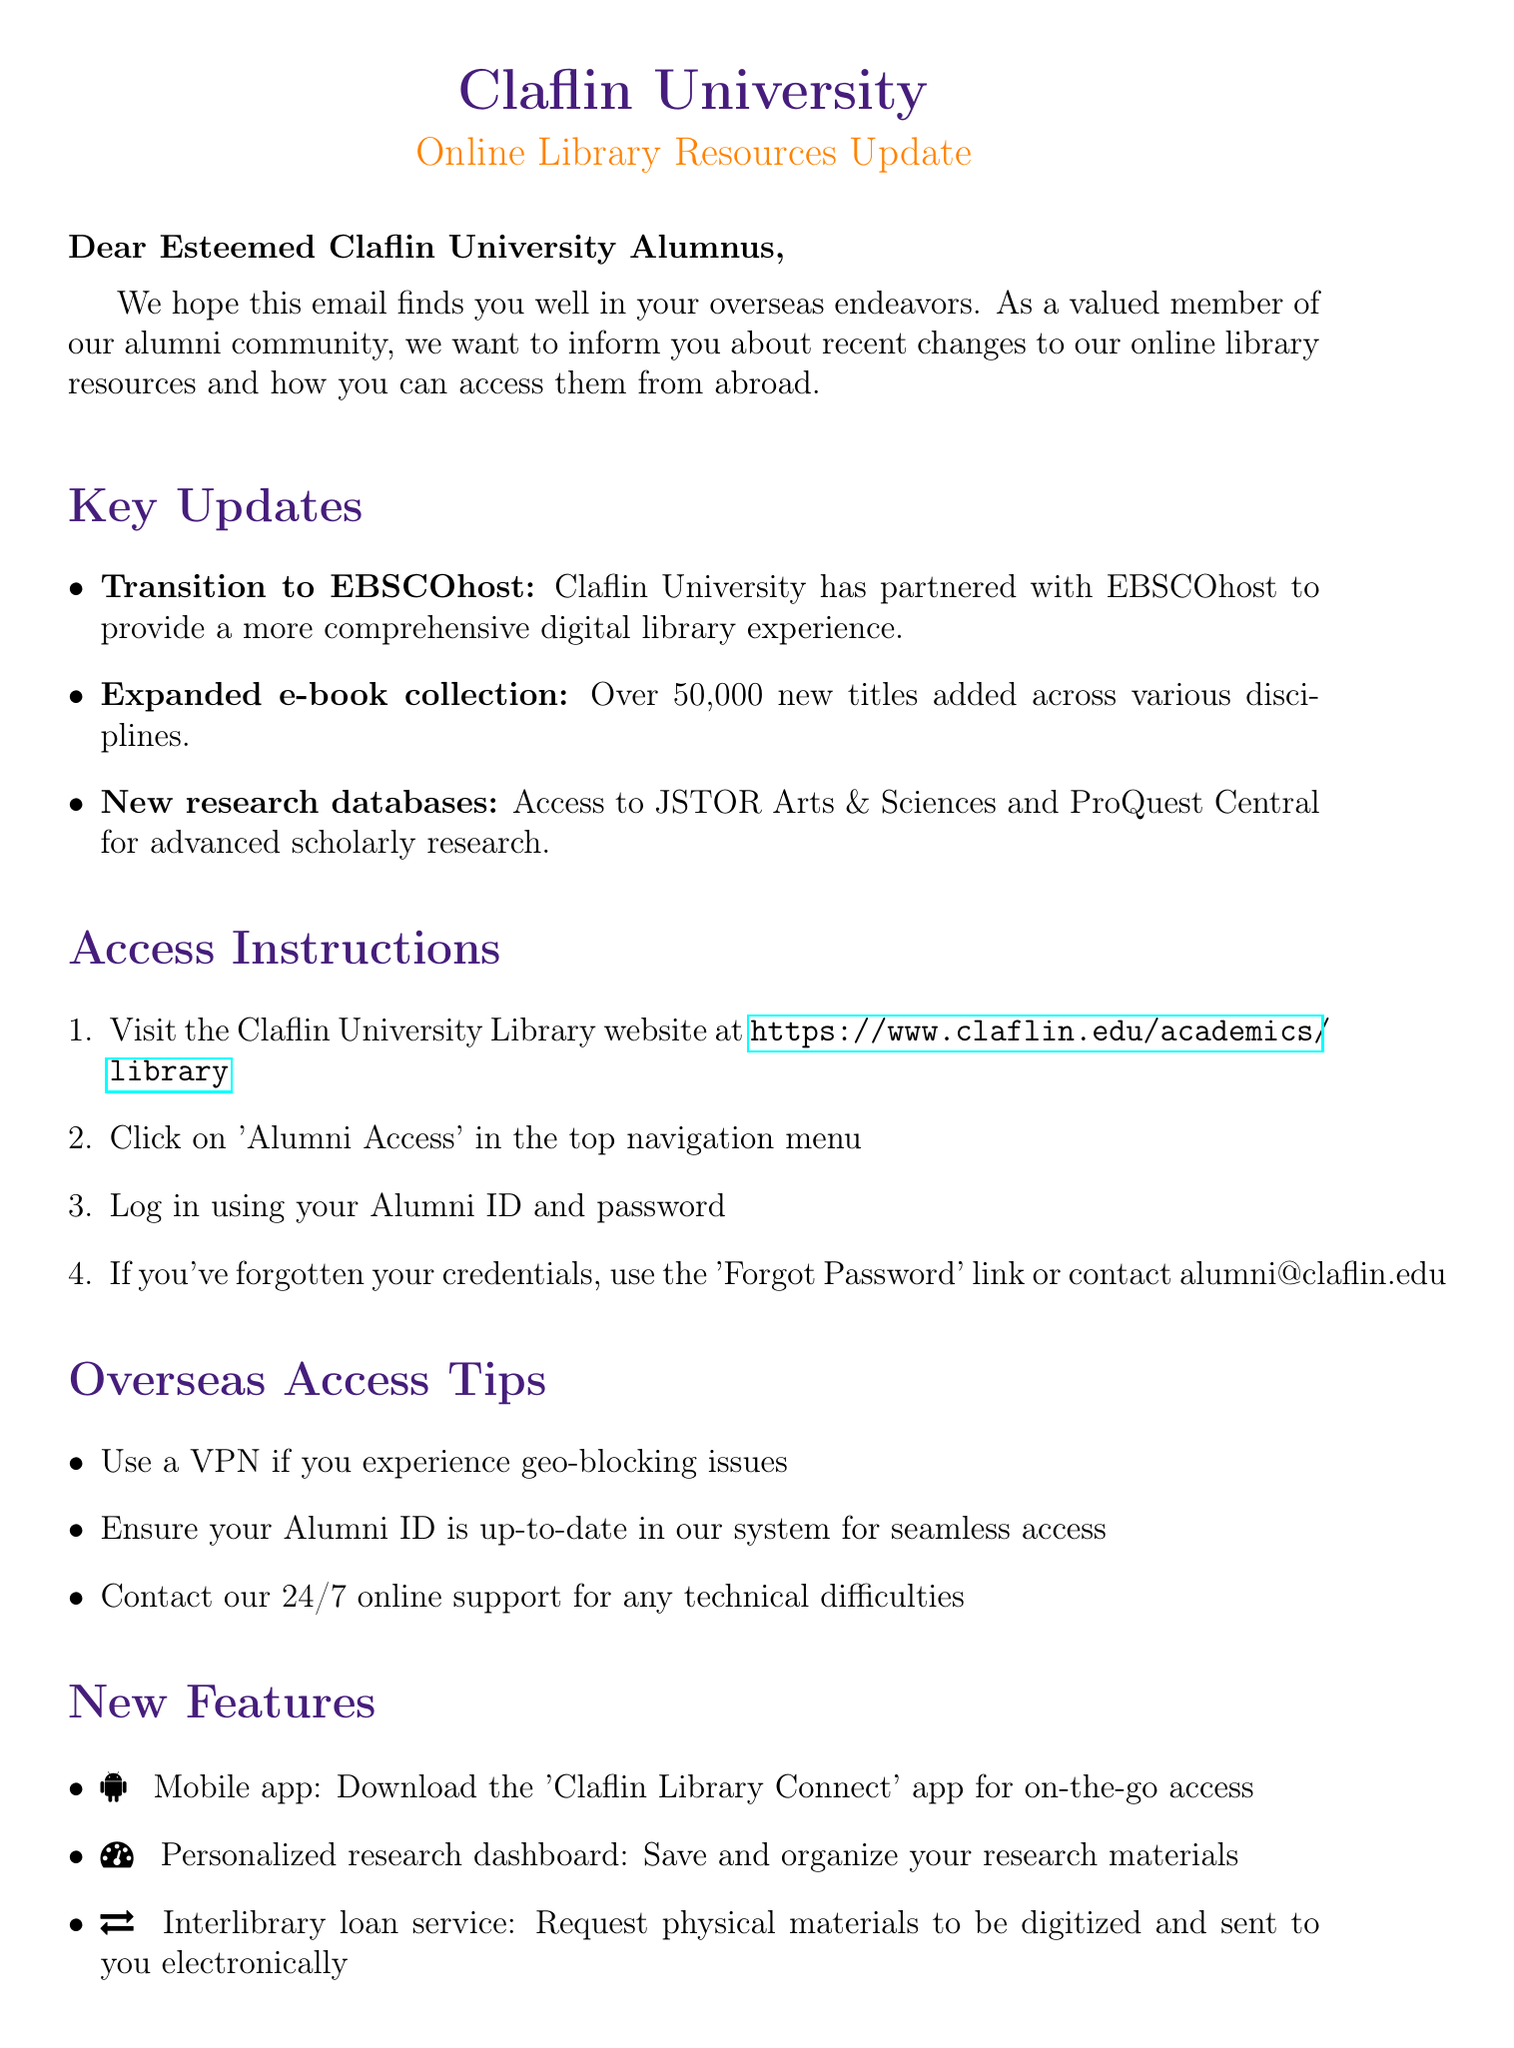What is the subject of the email? The subject line is an important part of an email, and it indicates the main topic being discussed.
Answer: Important Updates to Claflin University's Online Library Resources for Overseas Alumni Who is the Director of Library Services? Understanding the author's position can provide context for the information in the email.
Answer: Dr. Harriet Simpkins How many new titles have been added to the e-book collection? This piece of information highlights the extent of the library's new resources.
Answer: Over 50,000 What platform has Claflin University partnered with? This question seeks to identify the new service provided by the university to improve library access.
Answer: EBSCOhost What should you use if you experience geo-blocking issues? Knowing this can help users access resources without interruptions when abroad.
Answer: VPN What is one of the new features introduced in the library update? This question checks for specific enhancements that enrich user experience.
Answer: Mobile app Where can alumni find 'Alumni Access' in the library website? This inquiry focuses on the location of a critical functionality for alumni users.
Answer: Top navigation menu What email should alumni contact for assistance? This question provides necessary information for alumni who may need help with access issues.
Answer: alumni@claflin.edu 